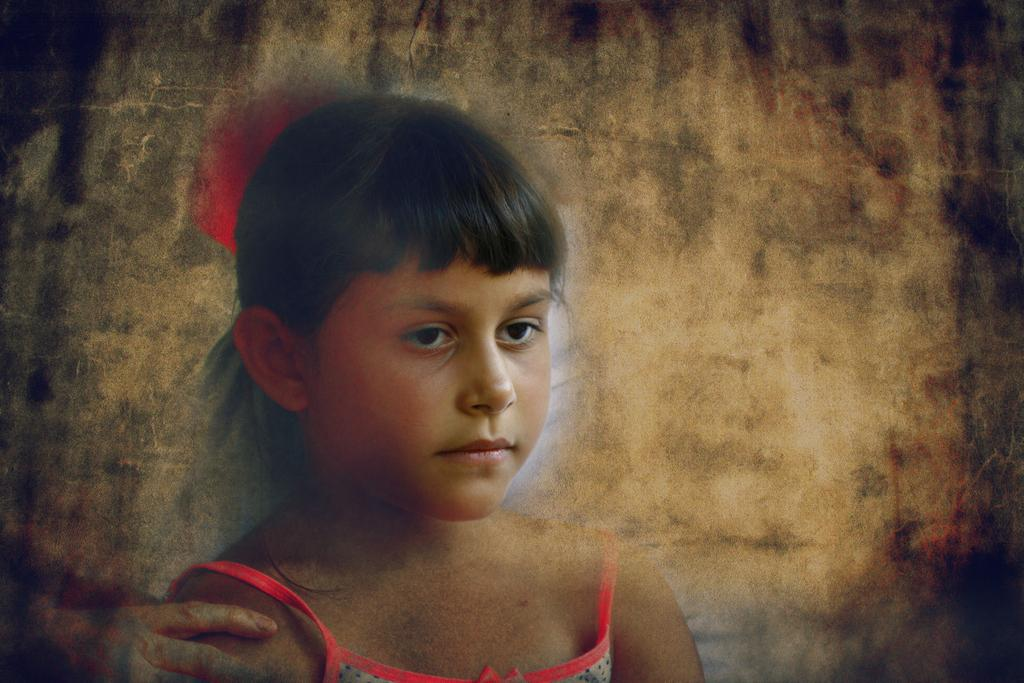Who is present in the image? There is a girl in the image. What can be seen in the background of the image? There is a wall in the background of the image. What type of zinc is being used to treat the girl's cough in the image? There is no mention of a hospital, zinc, or cough in the image, so it cannot be determined if any treatment is being administered or what type of zinc might be used. 